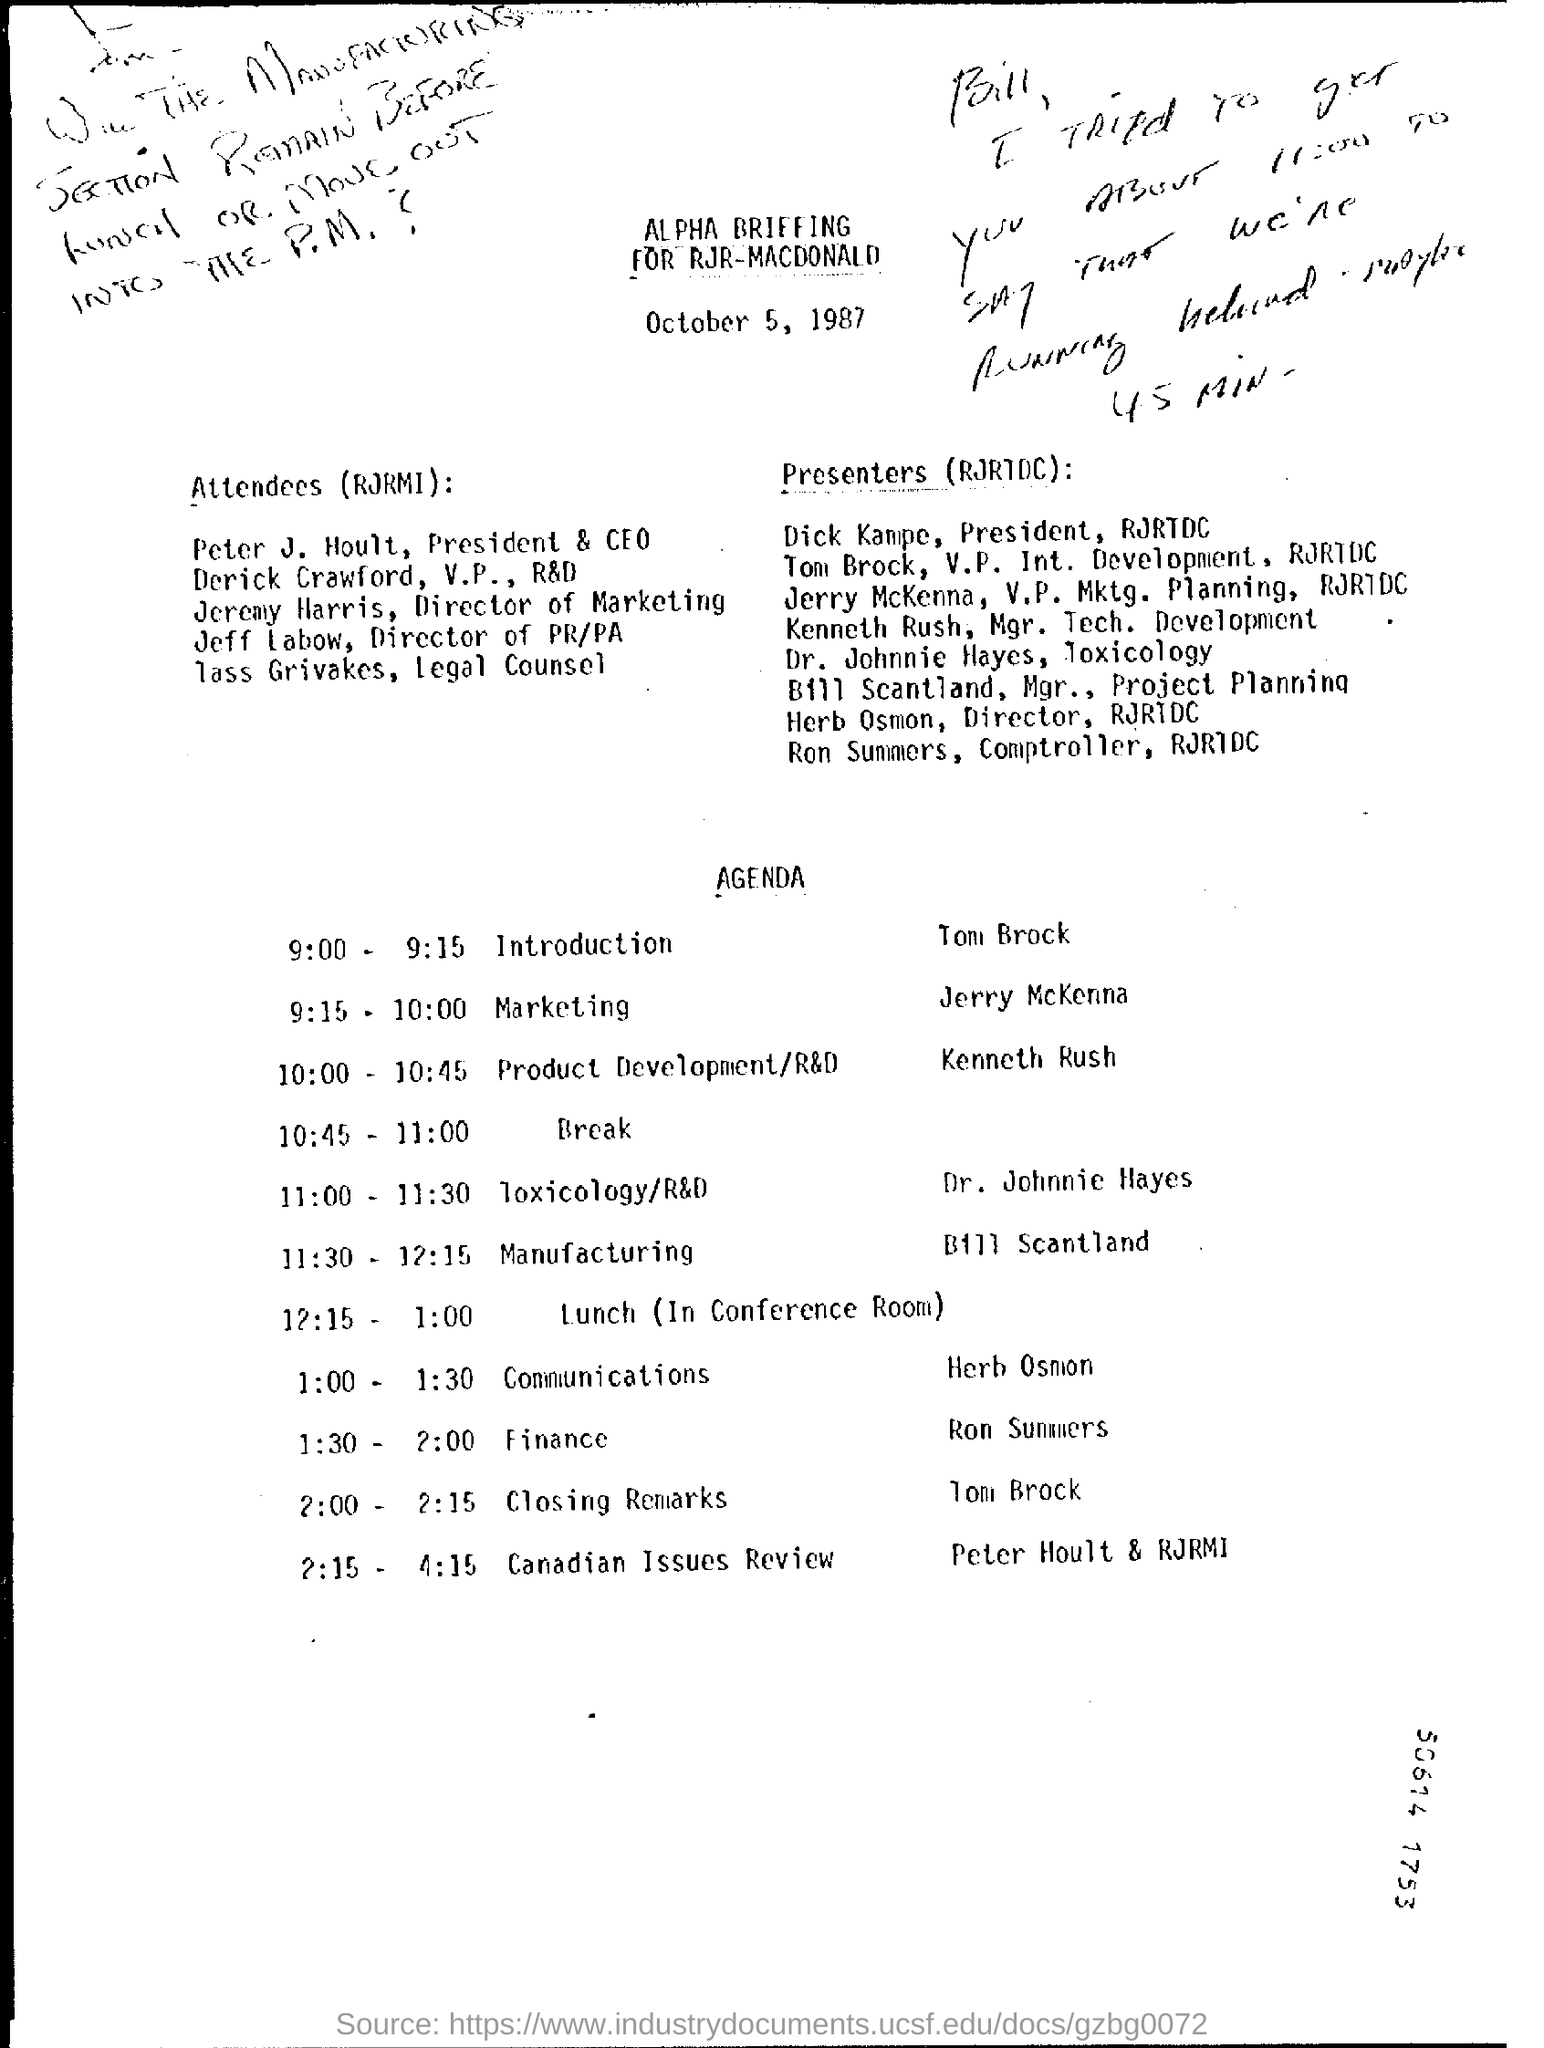What is the title of the given document?
Offer a very short reply. ALPHA BRIEFING FOR RJR-MACDONALD. Who gives the introduction?
Provide a succinct answer. Tom brock. 